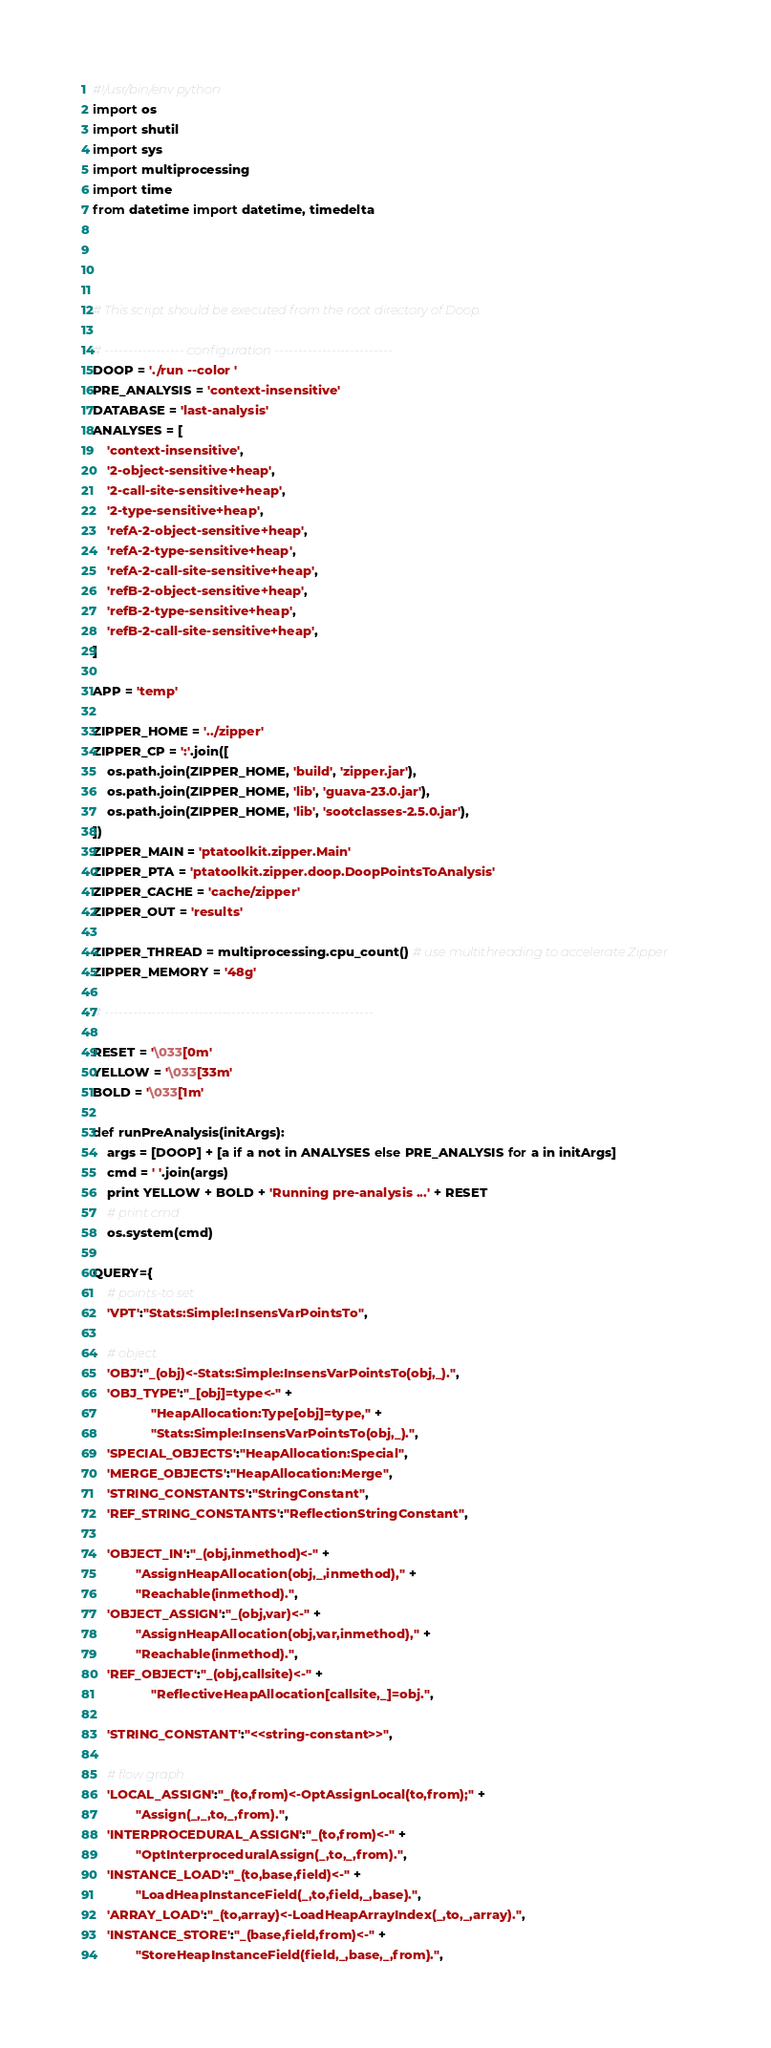Convert code to text. <code><loc_0><loc_0><loc_500><loc_500><_Python_>#!/usr/bin/env python
import os
import shutil
import sys
import multiprocessing
import time
from datetime import datetime, timedelta




# This script should be executed from the root directory of Doop.

# ----------------- configuration -------------------------
DOOP = './run --color '
PRE_ANALYSIS = 'context-insensitive'
DATABASE = 'last-analysis'
ANALYSES = [
    'context-insensitive',
    '2-object-sensitive+heap',
    '2-call-site-sensitive+heap',
    '2-type-sensitive+heap',          
    'refA-2-object-sensitive+heap',
    'refA-2-type-sensitive+heap',
    'refA-2-call-site-sensitive+heap',
    'refB-2-object-sensitive+heap',
    'refB-2-type-sensitive+heap',
    'refB-2-call-site-sensitive+heap',
]

APP = 'temp'

ZIPPER_HOME = '../zipper'
ZIPPER_CP = ':'.join([
    os.path.join(ZIPPER_HOME, 'build', 'zipper.jar'),
    os.path.join(ZIPPER_HOME, 'lib', 'guava-23.0.jar'),
    os.path.join(ZIPPER_HOME, 'lib', 'sootclasses-2.5.0.jar'),
])
ZIPPER_MAIN = 'ptatoolkit.zipper.Main'
ZIPPER_PTA = 'ptatoolkit.zipper.doop.DoopPointsToAnalysis'
ZIPPER_CACHE = 'cache/zipper'
ZIPPER_OUT = 'results'

ZIPPER_THREAD = multiprocessing.cpu_count() # use multithreading to accelerate Zipper
ZIPPER_MEMORY = '48g'

# ---------------------------------------------------------

RESET = '\033[0m'
YELLOW = '\033[33m'
BOLD = '\033[1m'

def runPreAnalysis(initArgs):
    args = [DOOP] + [a if a not in ANALYSES else PRE_ANALYSIS for a in initArgs]
    cmd = ' '.join(args)
    print YELLOW + BOLD + 'Running pre-analysis ...' + RESET
    # print cmd
    os.system(cmd)

QUERY={
    # points-to set
    'VPT':"Stats:Simple:InsensVarPointsTo",

    # object
    'OBJ':"_(obj)<-Stats:Simple:InsensVarPointsTo(obj,_).",
    'OBJ_TYPE':"_[obj]=type<-" +
                "HeapAllocation:Type[obj]=type," +
                "Stats:Simple:InsensVarPointsTo(obj,_).",
    'SPECIAL_OBJECTS':"HeapAllocation:Special",
    'MERGE_OBJECTS':"HeapAllocation:Merge",
    'STRING_CONSTANTS':"StringConstant",
    'REF_STRING_CONSTANTS':"ReflectionStringConstant",
    
    'OBJECT_IN':"_(obj,inmethod)<-" +
            "AssignHeapAllocation(obj,_,inmethod)," +
            "Reachable(inmethod).",
    'OBJECT_ASSIGN':"_(obj,var)<-" +
            "AssignHeapAllocation(obj,var,inmethod)," +
            "Reachable(inmethod).",
    'REF_OBJECT':"_(obj,callsite)<-" +
                "ReflectiveHeapAllocation[callsite,_]=obj.",

    'STRING_CONSTANT':"<<string-constant>>",

    # flow graph
    'LOCAL_ASSIGN':"_(to,from)<-OptAssignLocal(to,from);" +
            "Assign(_,_,to,_,from).",
    'INTERPROCEDURAL_ASSIGN':"_(to,from)<-" +
            "OptInterproceduralAssign(_,to,_,from).",
    'INSTANCE_LOAD':"_(to,base,field)<-" +
            "LoadHeapInstanceField(_,to,field,_,base).",
    'ARRAY_LOAD':"_(to,array)<-LoadHeapArrayIndex(_,to,_,array).",
    'INSTANCE_STORE':"_(base,field,from)<-" +
            "StoreHeapInstanceField(field,_,base,_,from).",</code> 